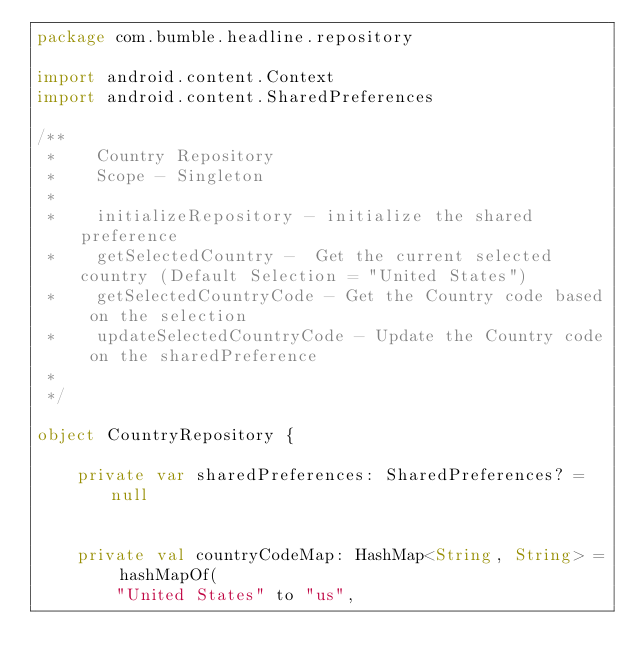<code> <loc_0><loc_0><loc_500><loc_500><_Kotlin_>package com.bumble.headline.repository

import android.content.Context
import android.content.SharedPreferences

/**
 *    Country Repository
 *    Scope - Singleton
 *
 *    initializeRepository - initialize the shared preference
 *    getSelectedCountry -  Get the current selected country (Default Selection = "United States")
 *    getSelectedCountryCode - Get the Country code based on the selection
 *    updateSelectedCountryCode - Update the Country code on the sharedPreference
 *
 */

object CountryRepository {

    private var sharedPreferences: SharedPreferences? = null


    private val countryCodeMap: HashMap<String, String> = hashMapOf(
        "United States" to "us",</code> 